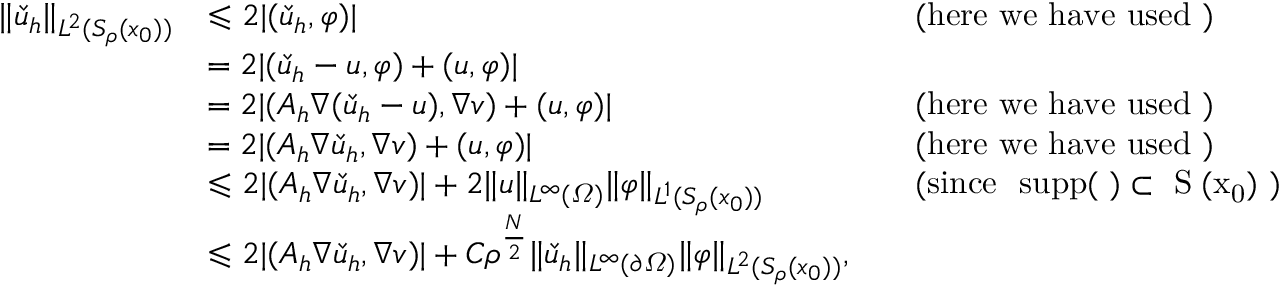Convert formula to latex. <formula><loc_0><loc_0><loc_500><loc_500>\begin{array} { r l r l } { \| \check { u } _ { h } \| _ { L ^ { 2 } ( S _ { \rho } ( x _ { 0 } ) ) } } & { \leqslant 2 | ( \check { u } _ { h } , \varphi ) | } & & { ( h e r e w e h a v e u s e d ) } \\ & { = 2 | ( \check { u } _ { h } - u , \varphi ) + ( u , \varphi ) | } \\ & { = 2 | ( A _ { h } \nabla ( \check { u } _ { h } - u ) , \nabla v ) + ( u , \varphi ) | } & & { ( h e r e w e h a v e u s e d ) } \\ & { = 2 | ( A _ { h } \nabla \check { u } _ { h } , \nabla v ) + ( u , \varphi ) | } & & { ( h e r e w e h a v e u s e d ) } \\ & { \leqslant 2 | ( A _ { h } \nabla \check { u } _ { h } , \nabla v ) | + 2 \| u \| _ { L ^ { \infty } ( \varOmega ) } \| \varphi \| _ { L ^ { 1 } ( S _ { \rho } ( x _ { 0 } ) ) } } & & { ( \sin c e \mathrm { s u p p } ( \varphi ) \subset S _ { \rho } ( x _ { 0 } ) ) } \\ & { \leqslant 2 | ( A _ { h } \nabla \check { u } _ { h } , \nabla v ) | + C \rho ^ { \frac { N } 2 } \| \check { u } _ { h } \| _ { L ^ { \infty } ( \partial \varOmega ) } \| \varphi \| _ { L ^ { 2 } ( S _ { \rho } ( x _ { 0 } ) ) } , } \end{array}</formula> 